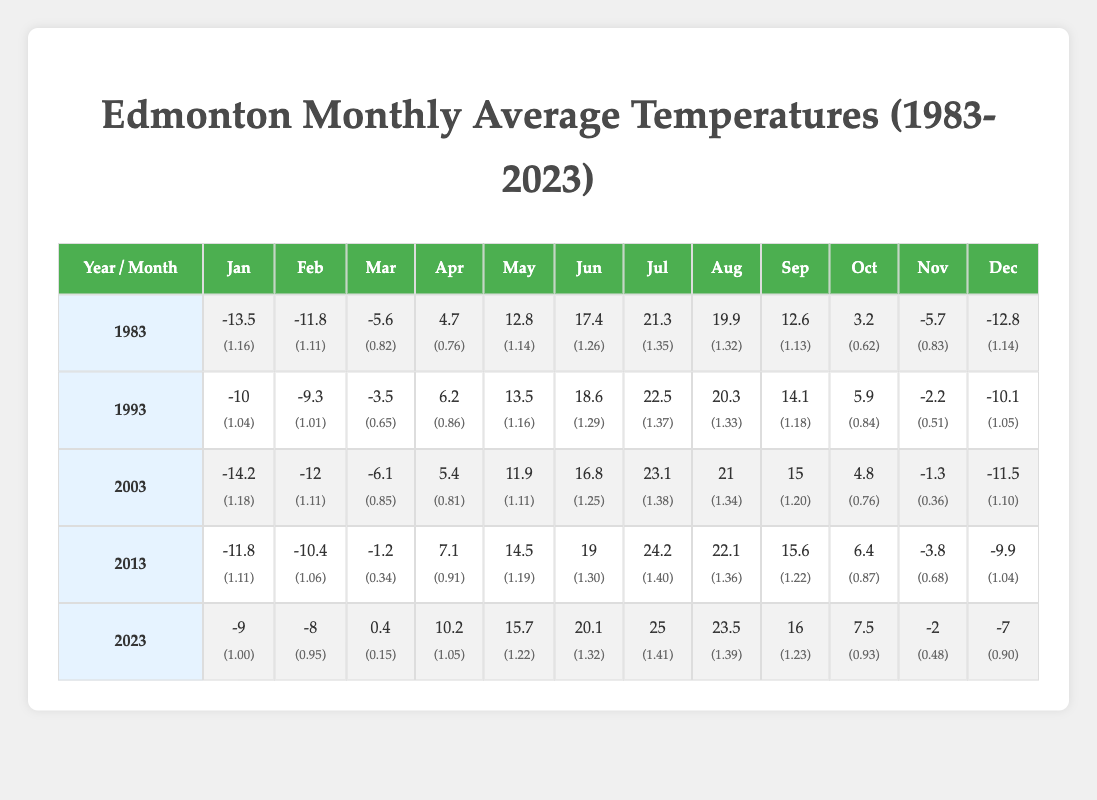What was the average temperature in July for the years listed? The temperatures for July over the years are as follows: 21.3 (1983), 22.5 (1993), 23.1 (2003), 24.2 (2013), and 25.0 (2023). Summing these gives 21.3 + 22.5 + 23.1 + 24.2 + 25.0 = 116.1. There are 5 data points, so the average is 116.1 / 5 = 23.22.
Answer: 23.22 In which year did Edmonton have the warmest January? By looking at January temperatures across the years: -13.5 (1983), -10.0 (1993), -14.2 (2003), -11.8 (2013), and -9.0 (2023), the warmest temperature is -9.0 in 2023.
Answer: 2023 Did the temperature in August rise every decade? Analyzing the August temperatures: 19.9 (1983), 20.3 (1993), 21.0 (2003), 22.1 (2013), and 23.5 (2023), we see the temperatures are increasing each decade.
Answer: Yes What is the difference in temperature between April in 1983 and April in 2023? The April temperatures are 4.7 (1983) and 10.2 (2023). The difference is calculated by subtracting: 10.2 - 4.7 = 5.5. Therefore, the temperature difference is 5.5 degrees.
Answer: 5.5 Which year had the lowest temperature in December? The December temperatures are as follows: -12.8 (1983), -10.1 (1993), -11.5 (2003), -9.9 (2013), and -7.0 (2023). The lowest temperature is -12.8 in 1983.
Answer: 1983 